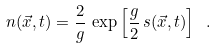<formula> <loc_0><loc_0><loc_500><loc_500>n ( \vec { x } , t ) = \frac { 2 } { g } \, \exp \left [ \frac { g } { 2 } \, s ( \vec { x } , t ) \right ] \ .</formula> 